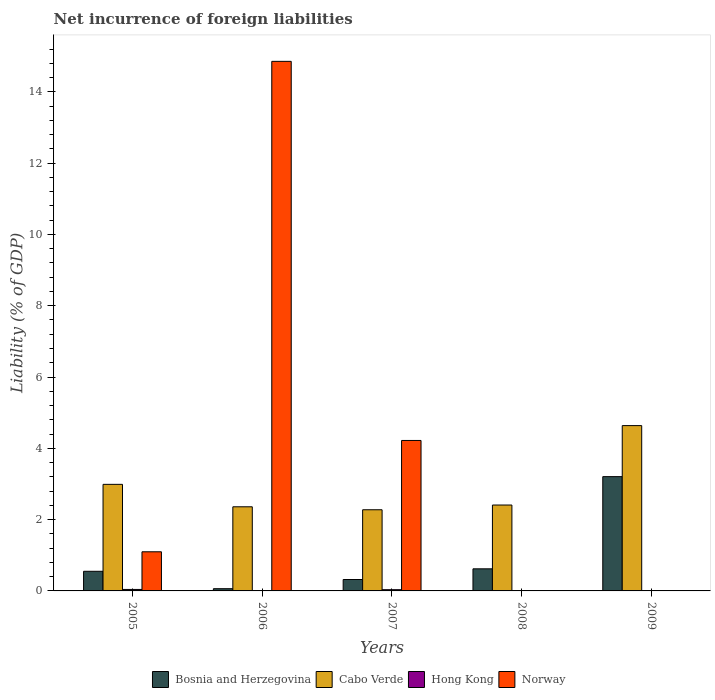How many different coloured bars are there?
Offer a terse response. 4. Are the number of bars per tick equal to the number of legend labels?
Offer a terse response. No. How many bars are there on the 3rd tick from the right?
Give a very brief answer. 4. What is the label of the 3rd group of bars from the left?
Your answer should be very brief. 2007. Across all years, what is the maximum net incurrence of foreign liabilities in Bosnia and Herzegovina?
Your answer should be very brief. 3.21. Across all years, what is the minimum net incurrence of foreign liabilities in Cabo Verde?
Offer a very short reply. 2.28. What is the total net incurrence of foreign liabilities in Bosnia and Herzegovina in the graph?
Your answer should be very brief. 4.76. What is the difference between the net incurrence of foreign liabilities in Bosnia and Herzegovina in 2006 and that in 2008?
Offer a terse response. -0.56. What is the difference between the net incurrence of foreign liabilities in Hong Kong in 2009 and the net incurrence of foreign liabilities in Norway in 2006?
Keep it short and to the point. -14.85. What is the average net incurrence of foreign liabilities in Hong Kong per year?
Give a very brief answer. 0.02. In the year 2007, what is the difference between the net incurrence of foreign liabilities in Norway and net incurrence of foreign liabilities in Hong Kong?
Ensure brevity in your answer.  4.19. What is the ratio of the net incurrence of foreign liabilities in Hong Kong in 2005 to that in 2007?
Your response must be concise. 1.2. What is the difference between the highest and the second highest net incurrence of foreign liabilities in Hong Kong?
Give a very brief answer. 0.01. What is the difference between the highest and the lowest net incurrence of foreign liabilities in Bosnia and Herzegovina?
Your answer should be very brief. 3.14. Is the sum of the net incurrence of foreign liabilities in Cabo Verde in 2007 and 2009 greater than the maximum net incurrence of foreign liabilities in Norway across all years?
Offer a very short reply. No. Are the values on the major ticks of Y-axis written in scientific E-notation?
Your response must be concise. No. Does the graph contain any zero values?
Keep it short and to the point. Yes. Where does the legend appear in the graph?
Provide a short and direct response. Bottom center. How are the legend labels stacked?
Your answer should be compact. Horizontal. What is the title of the graph?
Your response must be concise. Net incurrence of foreign liabilities. Does "Venezuela" appear as one of the legend labels in the graph?
Your response must be concise. No. What is the label or title of the X-axis?
Offer a terse response. Years. What is the label or title of the Y-axis?
Make the answer very short. Liability (% of GDP). What is the Liability (% of GDP) of Bosnia and Herzegovina in 2005?
Ensure brevity in your answer.  0.55. What is the Liability (% of GDP) of Cabo Verde in 2005?
Your response must be concise. 2.99. What is the Liability (% of GDP) in Hong Kong in 2005?
Offer a very short reply. 0.04. What is the Liability (% of GDP) of Norway in 2005?
Keep it short and to the point. 1.1. What is the Liability (% of GDP) in Bosnia and Herzegovina in 2006?
Ensure brevity in your answer.  0.06. What is the Liability (% of GDP) of Cabo Verde in 2006?
Your response must be concise. 2.36. What is the Liability (% of GDP) of Hong Kong in 2006?
Give a very brief answer. 0.01. What is the Liability (% of GDP) in Norway in 2006?
Your answer should be very brief. 14.85. What is the Liability (% of GDP) of Bosnia and Herzegovina in 2007?
Give a very brief answer. 0.32. What is the Liability (% of GDP) of Cabo Verde in 2007?
Your response must be concise. 2.28. What is the Liability (% of GDP) of Hong Kong in 2007?
Provide a short and direct response. 0.03. What is the Liability (% of GDP) in Norway in 2007?
Offer a very short reply. 4.22. What is the Liability (% of GDP) in Bosnia and Herzegovina in 2008?
Provide a succinct answer. 0.62. What is the Liability (% of GDP) in Cabo Verde in 2008?
Your response must be concise. 2.41. What is the Liability (% of GDP) of Bosnia and Herzegovina in 2009?
Provide a short and direct response. 3.21. What is the Liability (% of GDP) in Cabo Verde in 2009?
Offer a very short reply. 4.64. Across all years, what is the maximum Liability (% of GDP) of Bosnia and Herzegovina?
Offer a terse response. 3.21. Across all years, what is the maximum Liability (% of GDP) of Cabo Verde?
Ensure brevity in your answer.  4.64. Across all years, what is the maximum Liability (% of GDP) in Hong Kong?
Make the answer very short. 0.04. Across all years, what is the maximum Liability (% of GDP) of Norway?
Keep it short and to the point. 14.85. Across all years, what is the minimum Liability (% of GDP) of Bosnia and Herzegovina?
Your response must be concise. 0.06. Across all years, what is the minimum Liability (% of GDP) in Cabo Verde?
Offer a very short reply. 2.28. What is the total Liability (% of GDP) in Bosnia and Herzegovina in the graph?
Keep it short and to the point. 4.76. What is the total Liability (% of GDP) of Cabo Verde in the graph?
Your answer should be very brief. 14.67. What is the total Liability (% of GDP) in Hong Kong in the graph?
Your response must be concise. 0.09. What is the total Liability (% of GDP) of Norway in the graph?
Provide a short and direct response. 20.17. What is the difference between the Liability (% of GDP) in Bosnia and Herzegovina in 2005 and that in 2006?
Your response must be concise. 0.49. What is the difference between the Liability (% of GDP) of Cabo Verde in 2005 and that in 2006?
Provide a succinct answer. 0.63. What is the difference between the Liability (% of GDP) in Norway in 2005 and that in 2006?
Keep it short and to the point. -13.76. What is the difference between the Liability (% of GDP) in Bosnia and Herzegovina in 2005 and that in 2007?
Your answer should be compact. 0.23. What is the difference between the Liability (% of GDP) in Cabo Verde in 2005 and that in 2007?
Give a very brief answer. 0.71. What is the difference between the Liability (% of GDP) in Hong Kong in 2005 and that in 2007?
Make the answer very short. 0.01. What is the difference between the Liability (% of GDP) of Norway in 2005 and that in 2007?
Give a very brief answer. -3.12. What is the difference between the Liability (% of GDP) of Bosnia and Herzegovina in 2005 and that in 2008?
Offer a terse response. -0.07. What is the difference between the Liability (% of GDP) of Cabo Verde in 2005 and that in 2008?
Ensure brevity in your answer.  0.58. What is the difference between the Liability (% of GDP) in Bosnia and Herzegovina in 2005 and that in 2009?
Offer a terse response. -2.66. What is the difference between the Liability (% of GDP) in Cabo Verde in 2005 and that in 2009?
Offer a terse response. -1.65. What is the difference between the Liability (% of GDP) in Bosnia and Herzegovina in 2006 and that in 2007?
Your answer should be very brief. -0.26. What is the difference between the Liability (% of GDP) in Cabo Verde in 2006 and that in 2007?
Offer a very short reply. 0.08. What is the difference between the Liability (% of GDP) of Hong Kong in 2006 and that in 2007?
Offer a terse response. -0.02. What is the difference between the Liability (% of GDP) of Norway in 2006 and that in 2007?
Keep it short and to the point. 10.63. What is the difference between the Liability (% of GDP) in Bosnia and Herzegovina in 2006 and that in 2008?
Ensure brevity in your answer.  -0.56. What is the difference between the Liability (% of GDP) of Cabo Verde in 2006 and that in 2008?
Make the answer very short. -0.05. What is the difference between the Liability (% of GDP) of Bosnia and Herzegovina in 2006 and that in 2009?
Give a very brief answer. -3.14. What is the difference between the Liability (% of GDP) in Cabo Verde in 2006 and that in 2009?
Keep it short and to the point. -2.28. What is the difference between the Liability (% of GDP) of Cabo Verde in 2007 and that in 2008?
Your response must be concise. -0.13. What is the difference between the Liability (% of GDP) of Bosnia and Herzegovina in 2007 and that in 2009?
Keep it short and to the point. -2.89. What is the difference between the Liability (% of GDP) in Cabo Verde in 2007 and that in 2009?
Keep it short and to the point. -2.36. What is the difference between the Liability (% of GDP) of Bosnia and Herzegovina in 2008 and that in 2009?
Make the answer very short. -2.59. What is the difference between the Liability (% of GDP) in Cabo Verde in 2008 and that in 2009?
Offer a terse response. -2.23. What is the difference between the Liability (% of GDP) of Bosnia and Herzegovina in 2005 and the Liability (% of GDP) of Cabo Verde in 2006?
Your answer should be very brief. -1.81. What is the difference between the Liability (% of GDP) of Bosnia and Herzegovina in 2005 and the Liability (% of GDP) of Hong Kong in 2006?
Your answer should be very brief. 0.54. What is the difference between the Liability (% of GDP) of Bosnia and Herzegovina in 2005 and the Liability (% of GDP) of Norway in 2006?
Ensure brevity in your answer.  -14.3. What is the difference between the Liability (% of GDP) of Cabo Verde in 2005 and the Liability (% of GDP) of Hong Kong in 2006?
Provide a succinct answer. 2.98. What is the difference between the Liability (% of GDP) in Cabo Verde in 2005 and the Liability (% of GDP) in Norway in 2006?
Give a very brief answer. -11.86. What is the difference between the Liability (% of GDP) of Hong Kong in 2005 and the Liability (% of GDP) of Norway in 2006?
Keep it short and to the point. -14.81. What is the difference between the Liability (% of GDP) in Bosnia and Herzegovina in 2005 and the Liability (% of GDP) in Cabo Verde in 2007?
Ensure brevity in your answer.  -1.73. What is the difference between the Liability (% of GDP) of Bosnia and Herzegovina in 2005 and the Liability (% of GDP) of Hong Kong in 2007?
Your response must be concise. 0.52. What is the difference between the Liability (% of GDP) in Bosnia and Herzegovina in 2005 and the Liability (% of GDP) in Norway in 2007?
Make the answer very short. -3.67. What is the difference between the Liability (% of GDP) in Cabo Verde in 2005 and the Liability (% of GDP) in Hong Kong in 2007?
Your response must be concise. 2.95. What is the difference between the Liability (% of GDP) of Cabo Verde in 2005 and the Liability (% of GDP) of Norway in 2007?
Provide a short and direct response. -1.23. What is the difference between the Liability (% of GDP) of Hong Kong in 2005 and the Liability (% of GDP) of Norway in 2007?
Keep it short and to the point. -4.18. What is the difference between the Liability (% of GDP) in Bosnia and Herzegovina in 2005 and the Liability (% of GDP) in Cabo Verde in 2008?
Ensure brevity in your answer.  -1.86. What is the difference between the Liability (% of GDP) of Bosnia and Herzegovina in 2005 and the Liability (% of GDP) of Cabo Verde in 2009?
Your answer should be compact. -4.09. What is the difference between the Liability (% of GDP) of Bosnia and Herzegovina in 2006 and the Liability (% of GDP) of Cabo Verde in 2007?
Make the answer very short. -2.21. What is the difference between the Liability (% of GDP) in Bosnia and Herzegovina in 2006 and the Liability (% of GDP) in Hong Kong in 2007?
Offer a terse response. 0.03. What is the difference between the Liability (% of GDP) in Bosnia and Herzegovina in 2006 and the Liability (% of GDP) in Norway in 2007?
Ensure brevity in your answer.  -4.16. What is the difference between the Liability (% of GDP) of Cabo Verde in 2006 and the Liability (% of GDP) of Hong Kong in 2007?
Offer a very short reply. 2.33. What is the difference between the Liability (% of GDP) in Cabo Verde in 2006 and the Liability (% of GDP) in Norway in 2007?
Offer a very short reply. -1.86. What is the difference between the Liability (% of GDP) in Hong Kong in 2006 and the Liability (% of GDP) in Norway in 2007?
Give a very brief answer. -4.21. What is the difference between the Liability (% of GDP) in Bosnia and Herzegovina in 2006 and the Liability (% of GDP) in Cabo Verde in 2008?
Keep it short and to the point. -2.35. What is the difference between the Liability (% of GDP) of Bosnia and Herzegovina in 2006 and the Liability (% of GDP) of Cabo Verde in 2009?
Your answer should be very brief. -4.57. What is the difference between the Liability (% of GDP) of Bosnia and Herzegovina in 2007 and the Liability (% of GDP) of Cabo Verde in 2008?
Ensure brevity in your answer.  -2.09. What is the difference between the Liability (% of GDP) in Bosnia and Herzegovina in 2007 and the Liability (% of GDP) in Cabo Verde in 2009?
Provide a succinct answer. -4.32. What is the difference between the Liability (% of GDP) of Bosnia and Herzegovina in 2008 and the Liability (% of GDP) of Cabo Verde in 2009?
Your answer should be very brief. -4.02. What is the average Liability (% of GDP) in Bosnia and Herzegovina per year?
Keep it short and to the point. 0.95. What is the average Liability (% of GDP) in Cabo Verde per year?
Your response must be concise. 2.93. What is the average Liability (% of GDP) of Hong Kong per year?
Keep it short and to the point. 0.02. What is the average Liability (% of GDP) of Norway per year?
Provide a short and direct response. 4.03. In the year 2005, what is the difference between the Liability (% of GDP) in Bosnia and Herzegovina and Liability (% of GDP) in Cabo Verde?
Offer a very short reply. -2.44. In the year 2005, what is the difference between the Liability (% of GDP) of Bosnia and Herzegovina and Liability (% of GDP) of Hong Kong?
Offer a terse response. 0.51. In the year 2005, what is the difference between the Liability (% of GDP) in Bosnia and Herzegovina and Liability (% of GDP) in Norway?
Your answer should be compact. -0.55. In the year 2005, what is the difference between the Liability (% of GDP) of Cabo Verde and Liability (% of GDP) of Hong Kong?
Provide a short and direct response. 2.95. In the year 2005, what is the difference between the Liability (% of GDP) of Cabo Verde and Liability (% of GDP) of Norway?
Make the answer very short. 1.89. In the year 2005, what is the difference between the Liability (% of GDP) of Hong Kong and Liability (% of GDP) of Norway?
Make the answer very short. -1.06. In the year 2006, what is the difference between the Liability (% of GDP) of Bosnia and Herzegovina and Liability (% of GDP) of Cabo Verde?
Provide a succinct answer. -2.3. In the year 2006, what is the difference between the Liability (% of GDP) in Bosnia and Herzegovina and Liability (% of GDP) in Hong Kong?
Keep it short and to the point. 0.05. In the year 2006, what is the difference between the Liability (% of GDP) of Bosnia and Herzegovina and Liability (% of GDP) of Norway?
Offer a terse response. -14.79. In the year 2006, what is the difference between the Liability (% of GDP) of Cabo Verde and Liability (% of GDP) of Hong Kong?
Your answer should be compact. 2.35. In the year 2006, what is the difference between the Liability (% of GDP) in Cabo Verde and Liability (% of GDP) in Norway?
Offer a very short reply. -12.49. In the year 2006, what is the difference between the Liability (% of GDP) in Hong Kong and Liability (% of GDP) in Norway?
Provide a short and direct response. -14.84. In the year 2007, what is the difference between the Liability (% of GDP) in Bosnia and Herzegovina and Liability (% of GDP) in Cabo Verde?
Your answer should be compact. -1.96. In the year 2007, what is the difference between the Liability (% of GDP) in Bosnia and Herzegovina and Liability (% of GDP) in Hong Kong?
Your answer should be compact. 0.29. In the year 2007, what is the difference between the Liability (% of GDP) of Bosnia and Herzegovina and Liability (% of GDP) of Norway?
Provide a succinct answer. -3.9. In the year 2007, what is the difference between the Liability (% of GDP) in Cabo Verde and Liability (% of GDP) in Hong Kong?
Make the answer very short. 2.24. In the year 2007, what is the difference between the Liability (% of GDP) in Cabo Verde and Liability (% of GDP) in Norway?
Offer a terse response. -1.94. In the year 2007, what is the difference between the Liability (% of GDP) in Hong Kong and Liability (% of GDP) in Norway?
Offer a very short reply. -4.19. In the year 2008, what is the difference between the Liability (% of GDP) of Bosnia and Herzegovina and Liability (% of GDP) of Cabo Verde?
Provide a short and direct response. -1.79. In the year 2009, what is the difference between the Liability (% of GDP) in Bosnia and Herzegovina and Liability (% of GDP) in Cabo Verde?
Your response must be concise. -1.43. What is the ratio of the Liability (% of GDP) of Bosnia and Herzegovina in 2005 to that in 2006?
Keep it short and to the point. 8.79. What is the ratio of the Liability (% of GDP) in Cabo Verde in 2005 to that in 2006?
Your answer should be very brief. 1.27. What is the ratio of the Liability (% of GDP) of Hong Kong in 2005 to that in 2006?
Give a very brief answer. 3.59. What is the ratio of the Liability (% of GDP) in Norway in 2005 to that in 2006?
Offer a very short reply. 0.07. What is the ratio of the Liability (% of GDP) in Bosnia and Herzegovina in 2005 to that in 2007?
Give a very brief answer. 1.72. What is the ratio of the Liability (% of GDP) in Cabo Verde in 2005 to that in 2007?
Offer a terse response. 1.31. What is the ratio of the Liability (% of GDP) of Hong Kong in 2005 to that in 2007?
Make the answer very short. 1.2. What is the ratio of the Liability (% of GDP) of Norway in 2005 to that in 2007?
Offer a terse response. 0.26. What is the ratio of the Liability (% of GDP) in Bosnia and Herzegovina in 2005 to that in 2008?
Make the answer very short. 0.89. What is the ratio of the Liability (% of GDP) in Cabo Verde in 2005 to that in 2008?
Give a very brief answer. 1.24. What is the ratio of the Liability (% of GDP) of Bosnia and Herzegovina in 2005 to that in 2009?
Your answer should be very brief. 0.17. What is the ratio of the Liability (% of GDP) in Cabo Verde in 2005 to that in 2009?
Provide a succinct answer. 0.64. What is the ratio of the Liability (% of GDP) in Bosnia and Herzegovina in 2006 to that in 2007?
Your response must be concise. 0.2. What is the ratio of the Liability (% of GDP) in Cabo Verde in 2006 to that in 2007?
Your answer should be compact. 1.04. What is the ratio of the Liability (% of GDP) of Hong Kong in 2006 to that in 2007?
Keep it short and to the point. 0.34. What is the ratio of the Liability (% of GDP) of Norway in 2006 to that in 2007?
Your answer should be very brief. 3.52. What is the ratio of the Liability (% of GDP) of Bosnia and Herzegovina in 2006 to that in 2008?
Give a very brief answer. 0.1. What is the ratio of the Liability (% of GDP) in Cabo Verde in 2006 to that in 2008?
Your response must be concise. 0.98. What is the ratio of the Liability (% of GDP) of Bosnia and Herzegovina in 2006 to that in 2009?
Keep it short and to the point. 0.02. What is the ratio of the Liability (% of GDP) of Cabo Verde in 2006 to that in 2009?
Keep it short and to the point. 0.51. What is the ratio of the Liability (% of GDP) of Bosnia and Herzegovina in 2007 to that in 2008?
Keep it short and to the point. 0.52. What is the ratio of the Liability (% of GDP) in Cabo Verde in 2007 to that in 2008?
Make the answer very short. 0.94. What is the ratio of the Liability (% of GDP) of Bosnia and Herzegovina in 2007 to that in 2009?
Provide a succinct answer. 0.1. What is the ratio of the Liability (% of GDP) in Cabo Verde in 2007 to that in 2009?
Offer a very short reply. 0.49. What is the ratio of the Liability (% of GDP) of Bosnia and Herzegovina in 2008 to that in 2009?
Provide a short and direct response. 0.19. What is the ratio of the Liability (% of GDP) in Cabo Verde in 2008 to that in 2009?
Your response must be concise. 0.52. What is the difference between the highest and the second highest Liability (% of GDP) of Bosnia and Herzegovina?
Give a very brief answer. 2.59. What is the difference between the highest and the second highest Liability (% of GDP) of Cabo Verde?
Your response must be concise. 1.65. What is the difference between the highest and the second highest Liability (% of GDP) of Hong Kong?
Ensure brevity in your answer.  0.01. What is the difference between the highest and the second highest Liability (% of GDP) of Norway?
Provide a succinct answer. 10.63. What is the difference between the highest and the lowest Liability (% of GDP) of Bosnia and Herzegovina?
Your response must be concise. 3.14. What is the difference between the highest and the lowest Liability (% of GDP) of Cabo Verde?
Make the answer very short. 2.36. What is the difference between the highest and the lowest Liability (% of GDP) in Hong Kong?
Offer a terse response. 0.04. What is the difference between the highest and the lowest Liability (% of GDP) in Norway?
Make the answer very short. 14.85. 